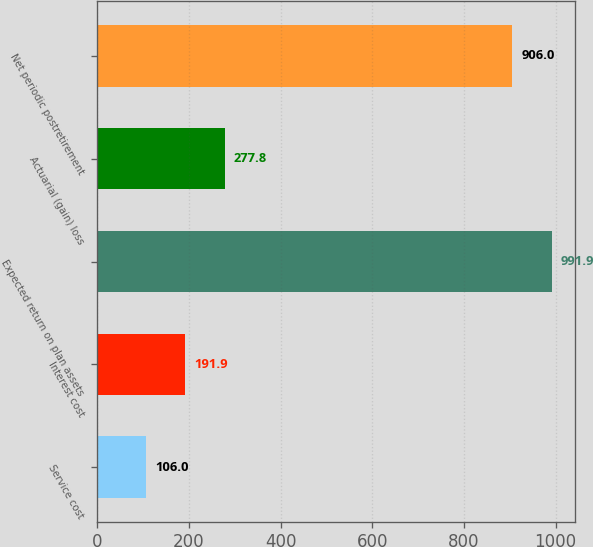Convert chart to OTSL. <chart><loc_0><loc_0><loc_500><loc_500><bar_chart><fcel>Service cost<fcel>Interest cost<fcel>Expected return on plan assets<fcel>Actuarial (gain) loss<fcel>Net periodic postretirement<nl><fcel>106<fcel>191.9<fcel>991.9<fcel>277.8<fcel>906<nl></chart> 